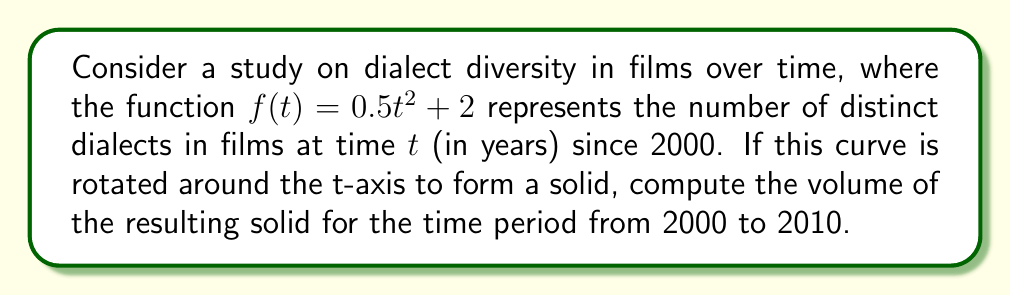What is the answer to this math problem? To solve this problem, we'll use the shell method for calculating the volume of a solid of revolution. The shell method is appropriate here because we're rotating around the t-axis (vertical axis).

The formula for the shell method is:

$$V = 2\pi \int_a^b f(t) \cdot t \, dt$$

Where:
- $V$ is the volume
- $a$ and $b$ are the lower and upper bounds of the integral
- $f(t)$ is the function being rotated
- $t$ is the distance from the axis of rotation

Steps:
1) Our function is $f(t) = 0.5t^2 + 2$
2) The time period is from 2000 to 2010, so $t$ goes from 0 to 10
3) Substituting into the formula:

   $$V = 2\pi \int_0^{10} (0.5t^2 + 2) \cdot t \, dt$$

4) Simplify the integrand:
   
   $$V = 2\pi \int_0^{10} (0.5t^3 + 2t) \, dt$$

5) Integrate:
   
   $$V = 2\pi \left[ \frac{0.5t^4}{4} + t^2 \right]_0^{10}$$

6) Evaluate the integral:
   
   $$V = 2\pi \left[ \left(\frac{0.5 \cdot 10^4}{4} + 10^2\right) - (0 + 0) \right]$$
   
   $$V = 2\pi (1250 + 100)$$
   
   $$V = 2\pi (1350)$$

7) Calculate the final result:
   
   $$V = 2700\pi$$

This result represents the volume in cubic units (likely cubic years, given the context).
Answer: $2700\pi$ cubic units 